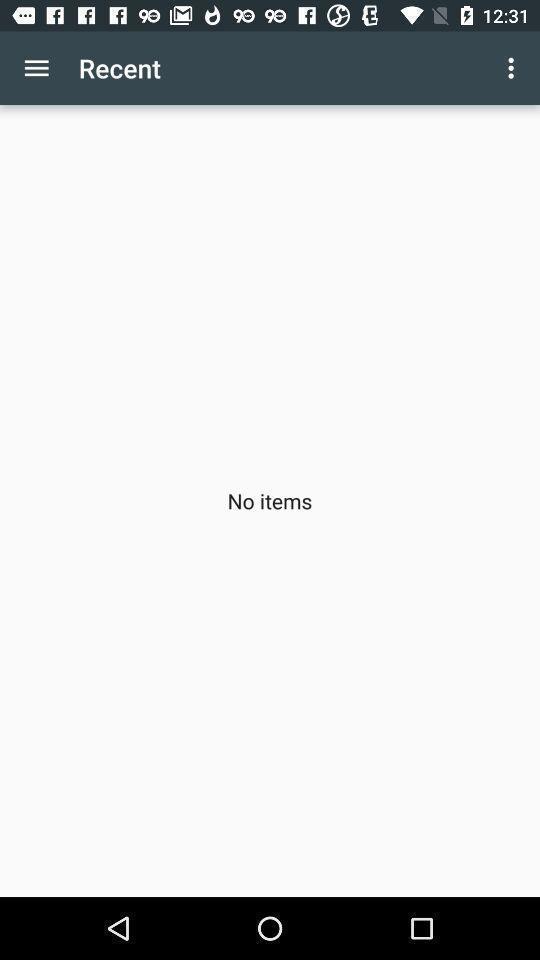Describe the visual elements of this screenshot. Screen shows recent page. 